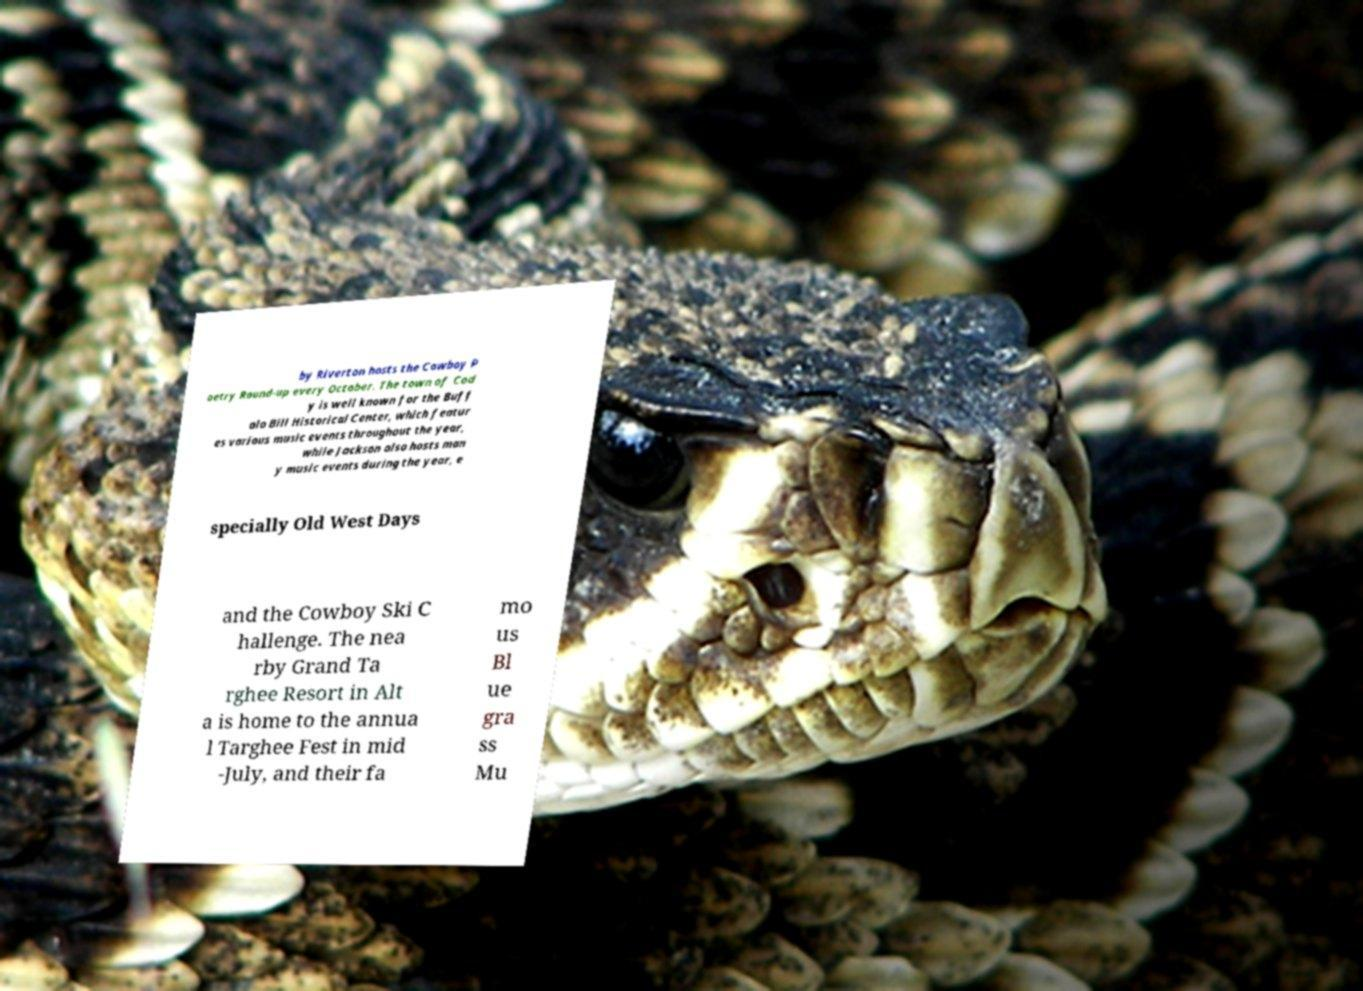Could you extract and type out the text from this image? by Riverton hosts the Cowboy P oetry Round-up every October. The town of Cod y is well known for the Buff alo Bill Historical Center, which featur es various music events throughout the year, while Jackson also hosts man y music events during the year, e specially Old West Days and the Cowboy Ski C hallenge. The nea rby Grand Ta rghee Resort in Alt a is home to the annua l Targhee Fest in mid -July, and their fa mo us Bl ue gra ss Mu 